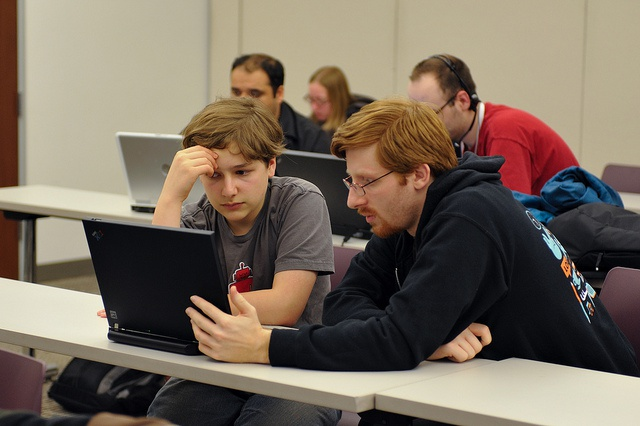Describe the objects in this image and their specific colors. I can see people in maroon, black, gray, and tan tones, people in maroon, black, gray, and tan tones, laptop in maroon, black, darkgray, and gray tones, people in maroon, brown, black, and gray tones, and people in maroon, black, brown, and tan tones in this image. 